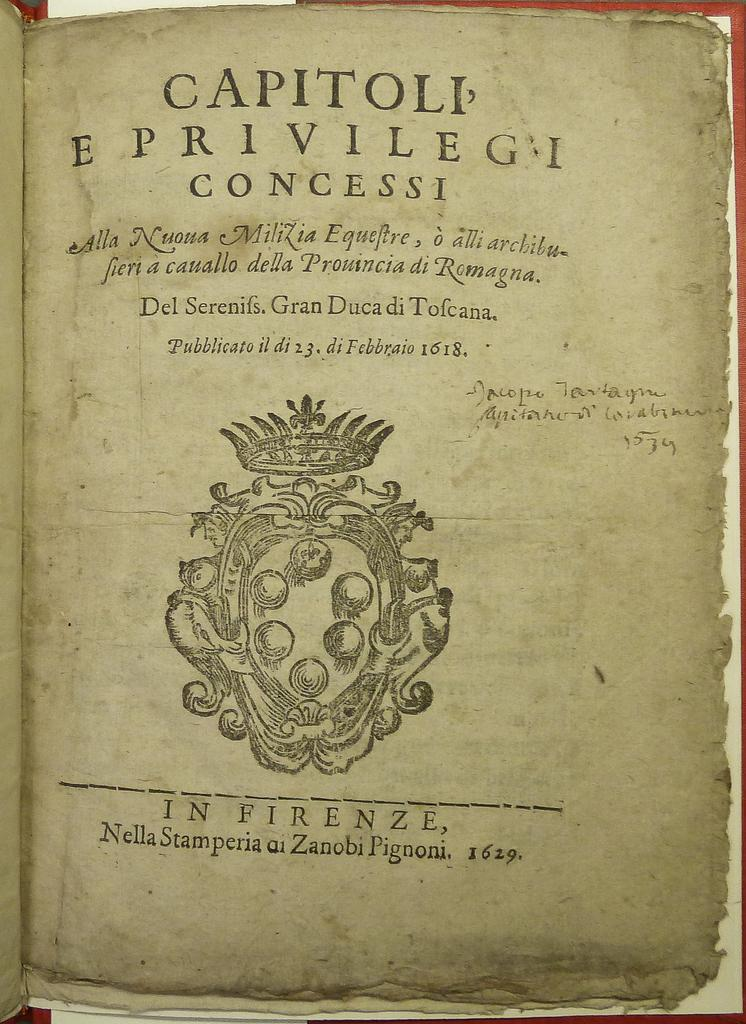Provide a one-sentence caption for the provided image. The book was written in the year of 1629. 